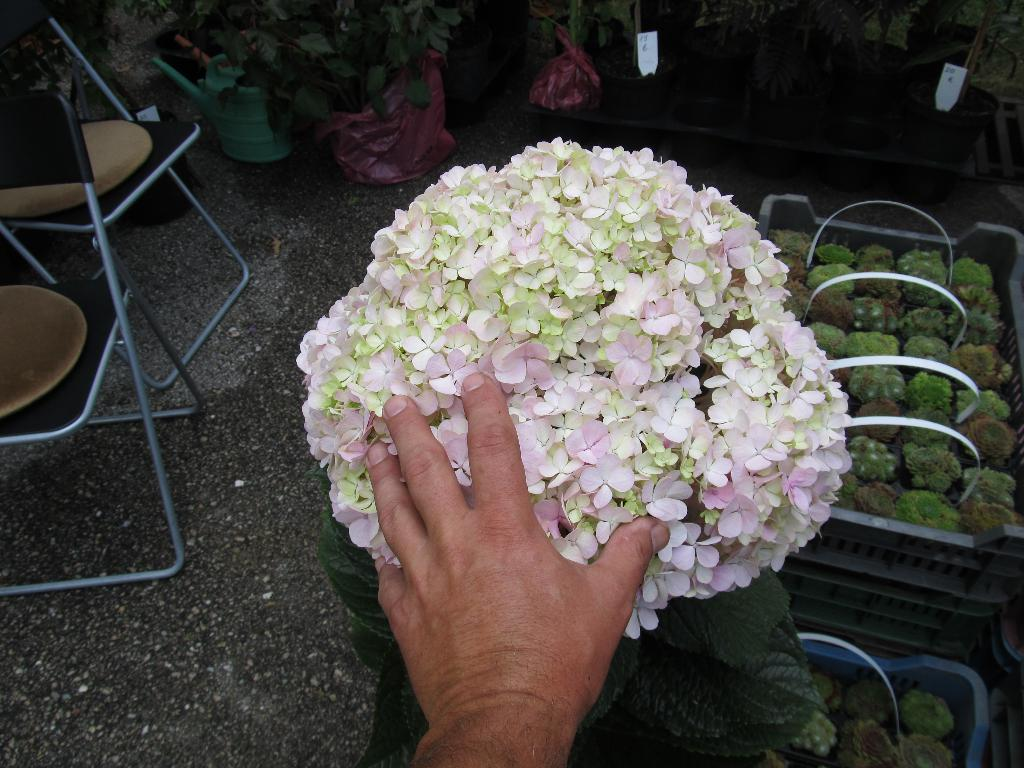What is the person in the image doing? The person is touching flowers in the image. What type of containers are the plants in? There are plants in pots and plastic containers in the image. What type of furniture is present in the image? There are chairs in the image. What type of hammer is being used to water the plants in the image? There is no hammer present in the image. Can you tell me the credit score of the person in the image? There is no information about the person's credit score in the image. 